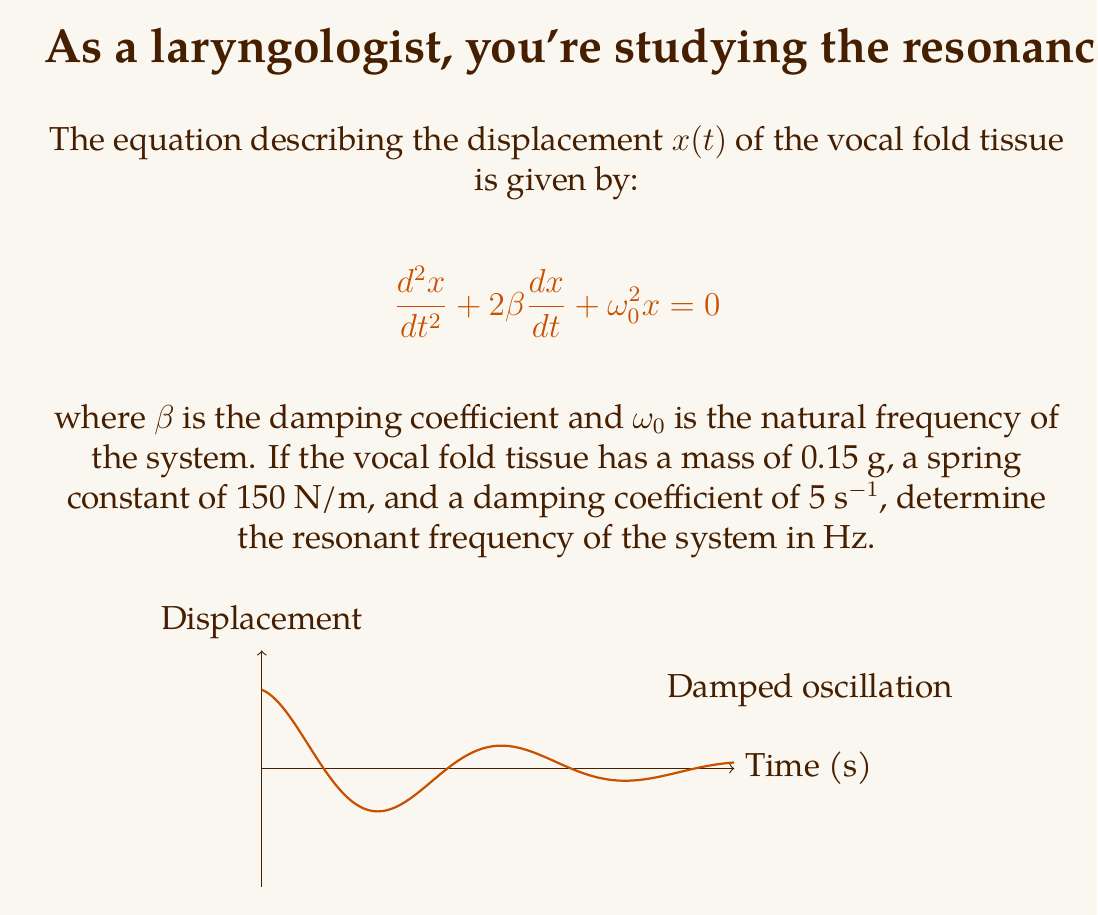Solve this math problem. Let's approach this step-by-step:

1) The natural frequency $\omega_0$ is given by:

   $$\omega_0 = \sqrt{\frac{k}{m}}$$

   where $k$ is the spring constant and $m$ is the mass.

2) Given:
   - Mass $m = 0.15$ g $= 1.5 \times 10^{-4}$ kg
   - Spring constant $k = 150$ N/m
   - Damping coefficient $\beta = 5$ s^-1

3) Calculate $\omega_0$:

   $$\omega_0 = \sqrt{\frac{150}{1.5 \times 10^{-4}}} = 1000 \text{ rad/s}$$

4) For a damped system, the resonant frequency $\omega_r$ is given by:

   $$\omega_r = \sqrt{\omega_0^2 - 2\beta^2}$$

5) Substitute the values:

   $$\omega_r = \sqrt{1000^2 - 2(5^2)} = \sqrt{1000000 - 50} = \sqrt{999950} \approx 999.97 \text{ rad/s}$$

6) Convert from rad/s to Hz by dividing by $2\pi$:

   $$f_r = \frac{\omega_r}{2\pi} = \frac{999.97}{2\pi} \approx 159.15 \text{ Hz}$$

Thus, the resonant frequency of the vocal fold tissue is approximately 159.15 Hz.
Answer: 159.15 Hz 